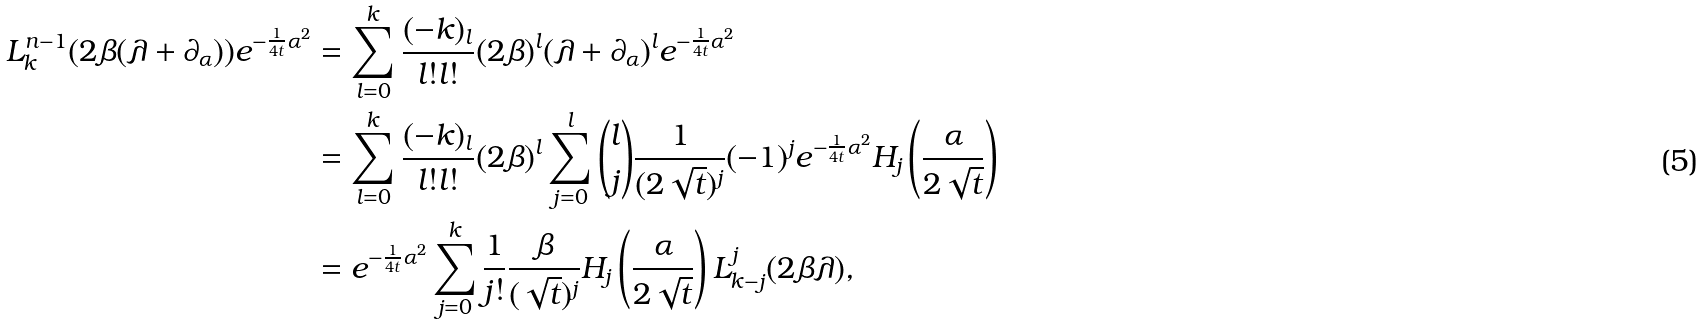<formula> <loc_0><loc_0><loc_500><loc_500>L _ { k } ^ { n - 1 } ( 2 \beta ( \lambda + \partial _ { \alpha } ) ) e ^ { - \frac { 1 } { 4 t } \alpha ^ { 2 } } & = \sum _ { l = 0 } ^ { k } \frac { ( - k ) _ { l } } { l ! l ! } ( 2 \beta ) ^ { l } ( \lambda + \partial _ { \alpha } ) ^ { l } e ^ { - \frac { 1 } { 4 t } \alpha ^ { 2 } } \\ & = \sum _ { l = 0 } ^ { k } \frac { ( - k ) _ { l } } { l ! l ! } ( 2 \beta ) ^ { l } \sum _ { j = 0 } ^ { l } \binom { l } { j } \frac { 1 } { ( 2 \sqrt { t } ) ^ { j } } ( - 1 ) ^ { j } e ^ { - \frac { 1 } { 4 t } \alpha ^ { 2 } } H _ { j } \left ( \frac { \alpha } { 2 \sqrt { t } } \right ) \\ & = e ^ { - \frac { 1 } { 4 t } \alpha ^ { 2 } } \sum _ { j = 0 } ^ { k } \frac { 1 } { j ! } \frac { \beta } { ( \sqrt { t } ) ^ { j } } H _ { j } \left ( \frac { \alpha } { 2 \sqrt { t } } \right ) L _ { k - j } ^ { j } ( 2 \beta \lambda ) ,</formula> 